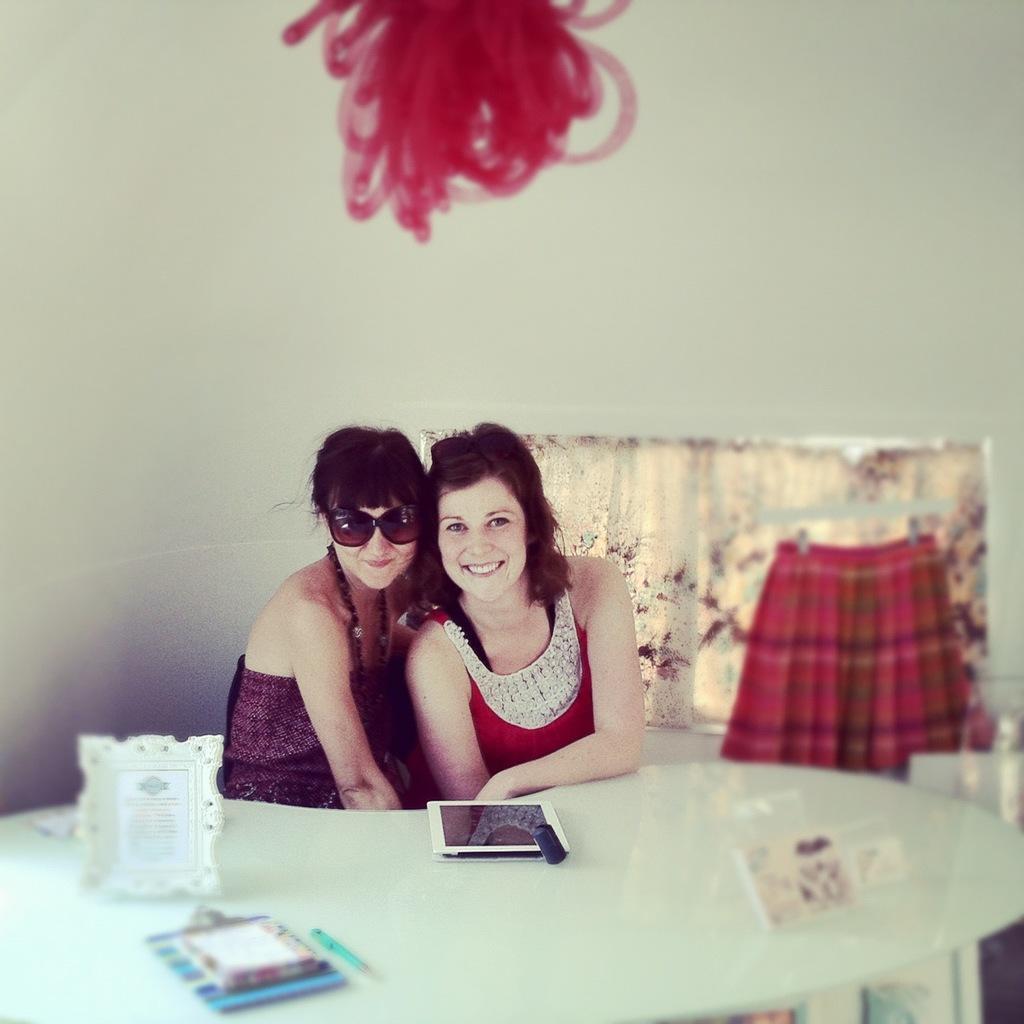Could you give a brief overview of what you see in this image? In this image we can see two women sitting in front of a table. One woman is wearing goggles. On the table we can see a mobile ,photo frame and a pen are placed on it. In the background ,we can see a cloth. 